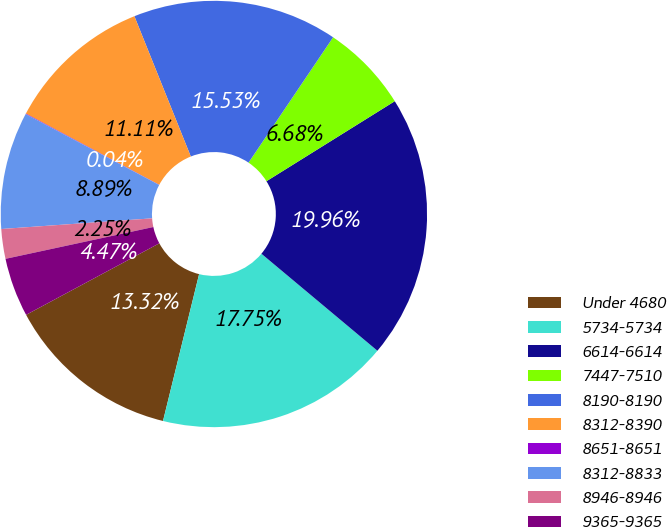<chart> <loc_0><loc_0><loc_500><loc_500><pie_chart><fcel>Under 4680<fcel>5734-5734<fcel>6614-6614<fcel>7447-7510<fcel>8190-8190<fcel>8312-8390<fcel>8651-8651<fcel>8312-8833<fcel>8946-8946<fcel>9365-9365<nl><fcel>13.32%<fcel>17.75%<fcel>19.96%<fcel>6.68%<fcel>15.53%<fcel>11.11%<fcel>0.04%<fcel>8.89%<fcel>2.25%<fcel>4.47%<nl></chart> 